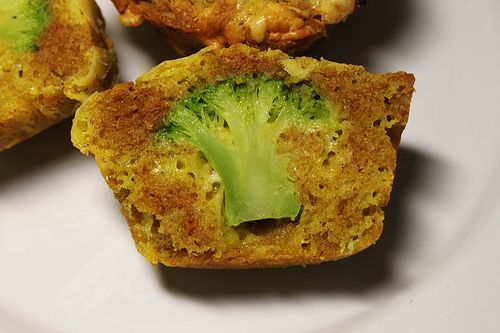<image>
Can you confirm if the broccoli is in the muffin? Yes. The broccoli is contained within or inside the muffin, showing a containment relationship. 